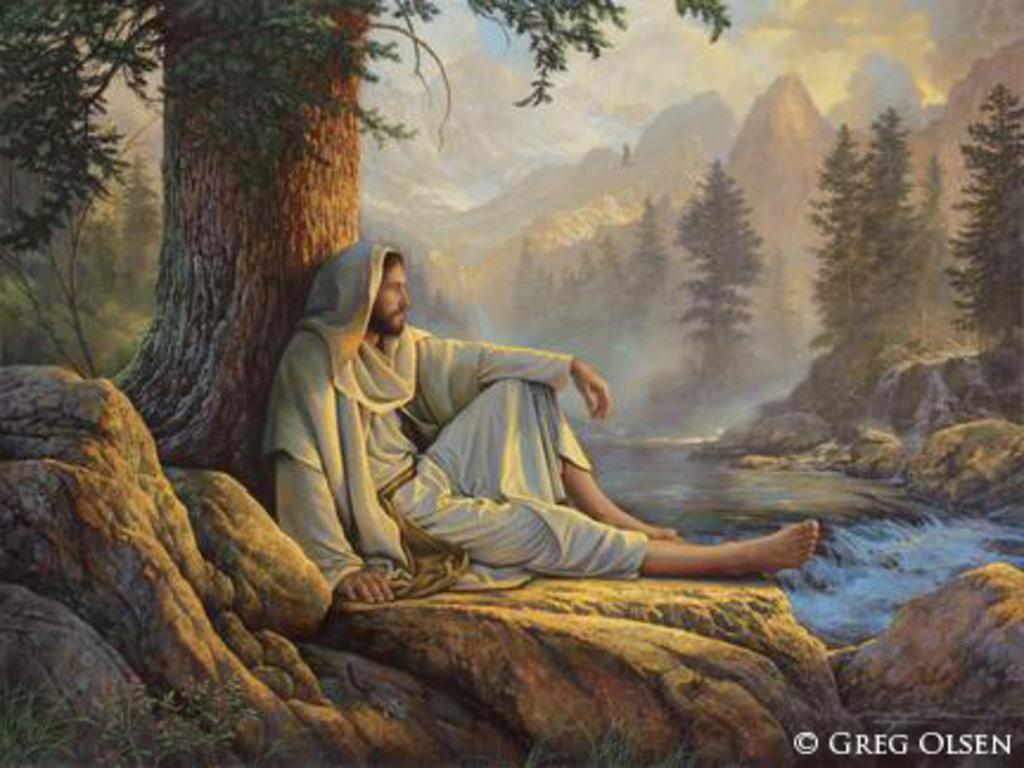Describe this image in one or two sentences. In this image, we can see a poster. Here a person is sitting on a rock near the tree trunk. Here we can see plants, rocks and water flow. Background we can see trees, hills and cloudy sky. Right side bottom corner, there is a watermark in the image. 